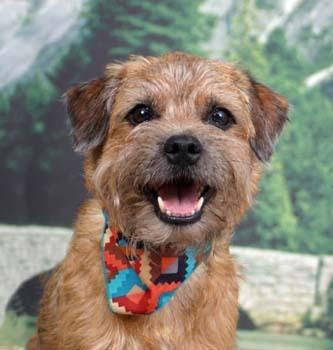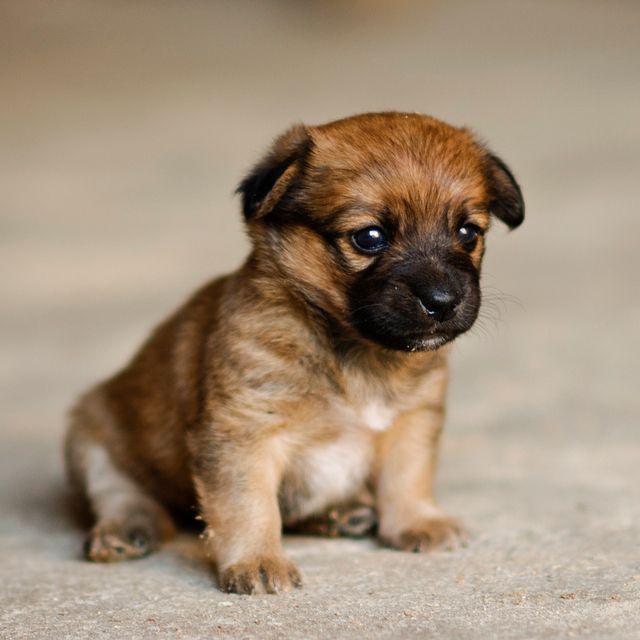The first image is the image on the left, the second image is the image on the right. For the images shown, is this caption "Left image shows one dog wearing something colorful around its neck." true? Answer yes or no. Yes. The first image is the image on the left, the second image is the image on the right. Given the left and right images, does the statement "One puppy is wearing a colorful color." hold true? Answer yes or no. Yes. 